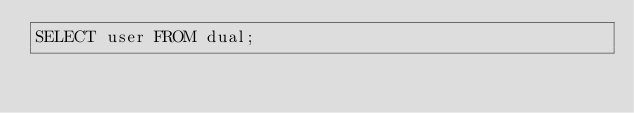Convert code to text. <code><loc_0><loc_0><loc_500><loc_500><_SQL_>SELECT user FROM dual;
</code> 